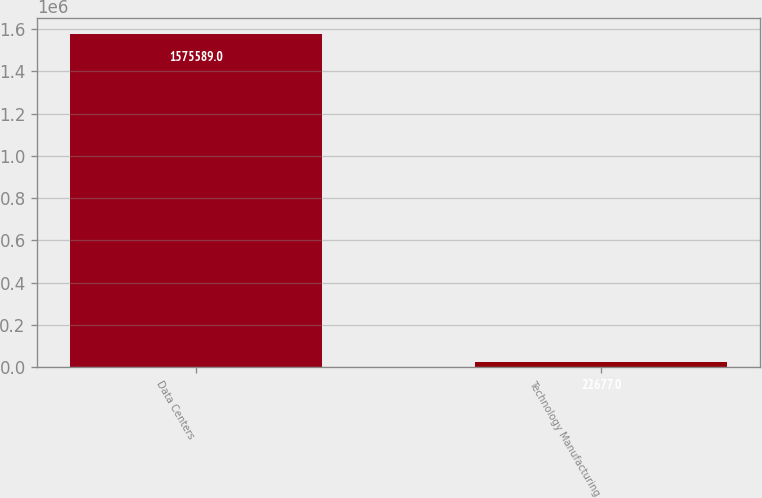Convert chart. <chart><loc_0><loc_0><loc_500><loc_500><bar_chart><fcel>Data Centers<fcel>Technology Manufacturing<nl><fcel>1.57559e+06<fcel>22677<nl></chart> 